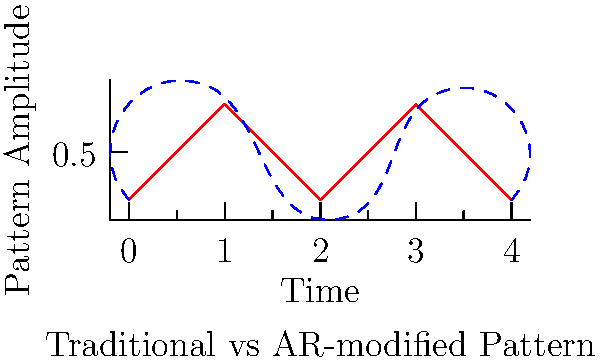In the graph above, the red solid line represents a traditional art pattern, while the blue dashed line shows the same pattern recreated in augmented reality (AR). If we define the pattern's complexity as the area between the two curves, calculate the approximate complexity increase (in square units) introduced by the AR recreation in the interval $[0,4]$. To calculate the complexity increase, we need to estimate the area between the two curves. Let's break this down step-by-step:

1) Divide the interval $[0,4]$ into 4 equal subintervals: $[0,1]$, $[1,2]$, $[2,3]$, and $[3,4]$.

2) For each subinterval, estimate the average difference in height between the two curves:
   $[0,1]$: Approximately 0.1 units
   $[1,2]$: Approximately 0.2 units
   $[2,3]$: Approximately 0.3 units
   $[3,4]$: Approximately 0.1 units

3) Calculate the area for each subinterval:
   $[0,1]$: $1 \times 0.1 = 0.1$ sq units
   $[1,2]$: $1 \times 0.2 = 0.2$ sq units
   $[2,3]$: $1 \times 0.3 = 0.3$ sq units
   $[3,4]$: $1 \times 0.1 = 0.1$ sq units

4) Sum up the areas:
   Total area = $0.1 + 0.2 + 0.3 + 0.1 = 0.7$ sq units

Therefore, the approximate complexity increase introduced by the AR recreation is 0.7 square units.
Answer: 0.7 square units 